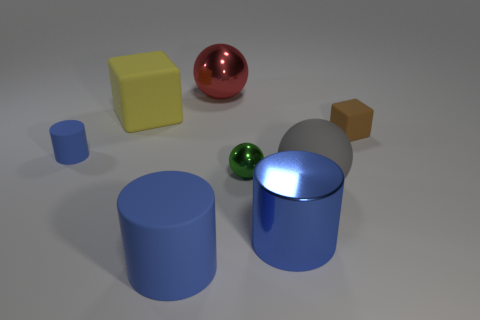Subtract all big balls. How many balls are left? 1 Add 1 small red matte cubes. How many objects exist? 9 Subtract all green balls. How many balls are left? 2 Add 2 big red spheres. How many big red spheres are left? 3 Add 4 large red objects. How many large red objects exist? 5 Subtract 0 red cylinders. How many objects are left? 8 Subtract all cylinders. How many objects are left? 5 Subtract 2 balls. How many balls are left? 1 Subtract all brown spheres. Subtract all blue blocks. How many spheres are left? 3 Subtract all green cylinders. How many gray balls are left? 1 